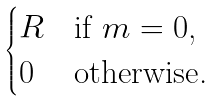Convert formula to latex. <formula><loc_0><loc_0><loc_500><loc_500>\begin{cases} R & \text {if $m = 0$,} \\ 0 & \text {otherwise.} \end{cases}</formula> 